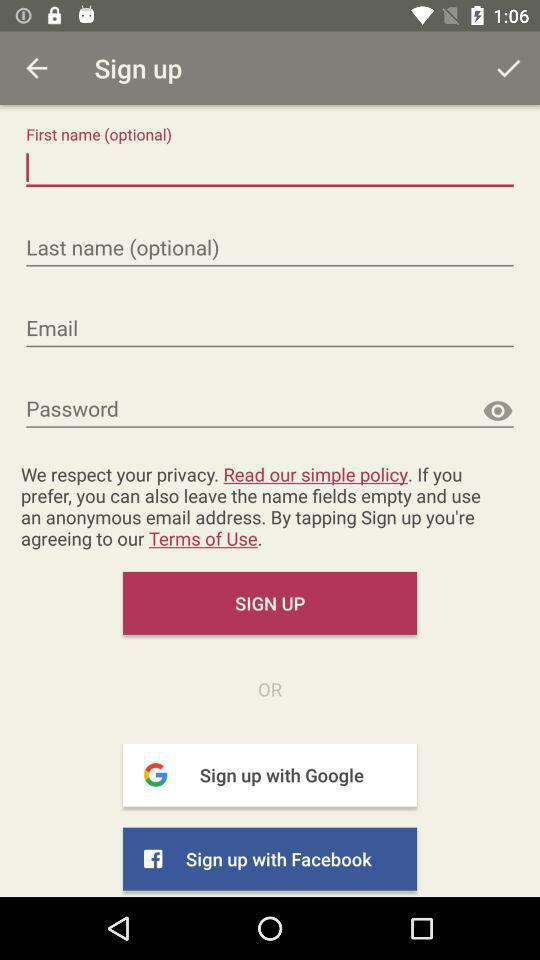How many inputs are required to sign up?
Answer the question using a single word or phrase. 4 